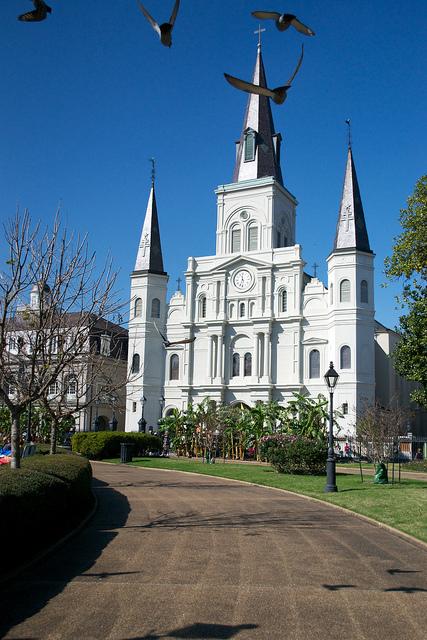Is there a clock tower?
Answer briefly. Yes. How many birds are in the picture?
Be succinct. 4. Are the houses on ground level?
Quick response, please. Yes. What city is this located in?
Concise answer only. London. What type of building is this?
Give a very brief answer. Church. Is the sky blue?
Concise answer only. Yes. 